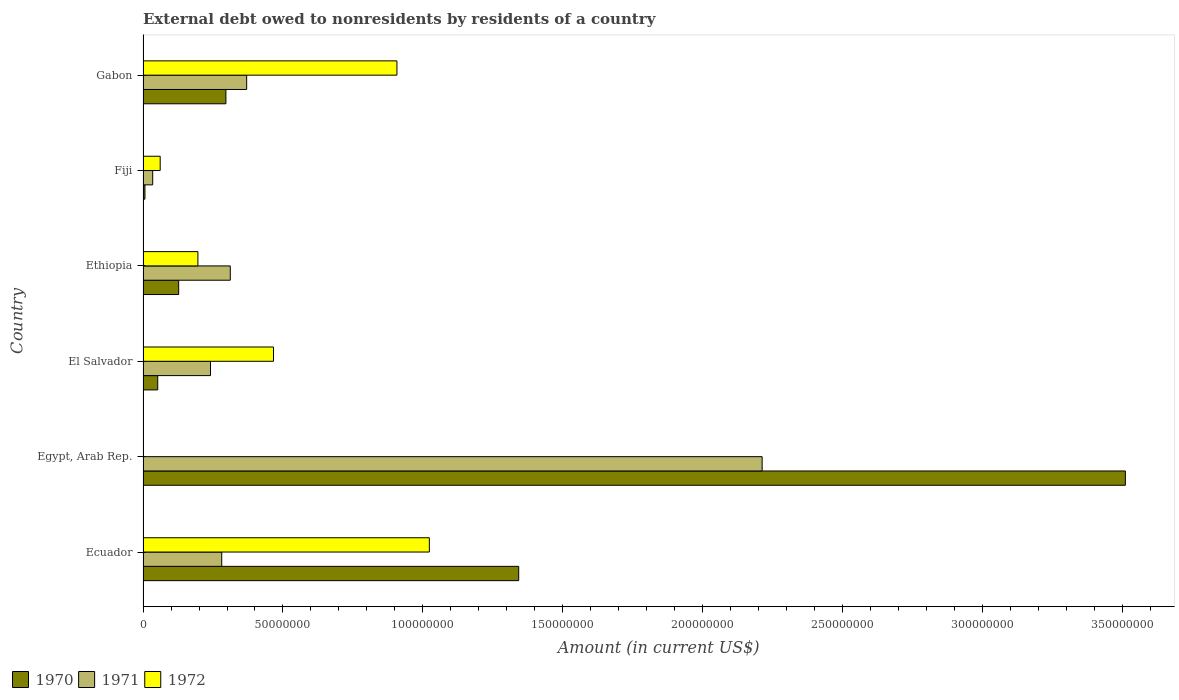How many groups of bars are there?
Offer a very short reply. 6. Are the number of bars per tick equal to the number of legend labels?
Your answer should be compact. No. Are the number of bars on each tick of the Y-axis equal?
Provide a short and direct response. No. How many bars are there on the 2nd tick from the top?
Your answer should be compact. 3. How many bars are there on the 5th tick from the bottom?
Your response must be concise. 3. What is the label of the 6th group of bars from the top?
Make the answer very short. Ecuador. What is the external debt owed by residents in 1970 in El Salvador?
Offer a very short reply. 5.25e+06. Across all countries, what is the maximum external debt owed by residents in 1971?
Ensure brevity in your answer.  2.21e+08. Across all countries, what is the minimum external debt owed by residents in 1970?
Provide a short and direct response. 6.77e+05. In which country was the external debt owed by residents in 1971 maximum?
Give a very brief answer. Egypt, Arab Rep. What is the total external debt owed by residents in 1971 in the graph?
Give a very brief answer. 3.45e+08. What is the difference between the external debt owed by residents in 1971 in Ethiopia and that in Fiji?
Keep it short and to the point. 2.77e+07. What is the difference between the external debt owed by residents in 1970 in El Salvador and the external debt owed by residents in 1972 in Ecuador?
Your response must be concise. -9.71e+07. What is the average external debt owed by residents in 1970 per country?
Give a very brief answer. 8.89e+07. What is the difference between the external debt owed by residents in 1971 and external debt owed by residents in 1970 in Egypt, Arab Rep.?
Ensure brevity in your answer.  -1.30e+08. In how many countries, is the external debt owed by residents in 1970 greater than 260000000 US$?
Your answer should be compact. 1. What is the ratio of the external debt owed by residents in 1970 in Egypt, Arab Rep. to that in Ethiopia?
Provide a succinct answer. 27.59. Is the difference between the external debt owed by residents in 1971 in Fiji and Gabon greater than the difference between the external debt owed by residents in 1970 in Fiji and Gabon?
Your answer should be compact. No. What is the difference between the highest and the second highest external debt owed by residents in 1970?
Offer a terse response. 2.17e+08. What is the difference between the highest and the lowest external debt owed by residents in 1971?
Your response must be concise. 2.18e+08. In how many countries, is the external debt owed by residents in 1970 greater than the average external debt owed by residents in 1970 taken over all countries?
Keep it short and to the point. 2. How many bars are there?
Your response must be concise. 17. How many countries are there in the graph?
Ensure brevity in your answer.  6. What is the difference between two consecutive major ticks on the X-axis?
Keep it short and to the point. 5.00e+07. Are the values on the major ticks of X-axis written in scientific E-notation?
Provide a short and direct response. No. Does the graph contain grids?
Make the answer very short. No. Where does the legend appear in the graph?
Provide a succinct answer. Bottom left. How are the legend labels stacked?
Make the answer very short. Horizontal. What is the title of the graph?
Make the answer very short. External debt owed to nonresidents by residents of a country. What is the label or title of the Y-axis?
Offer a very short reply. Country. What is the Amount (in current US$) in 1970 in Ecuador?
Offer a terse response. 1.34e+08. What is the Amount (in current US$) of 1971 in Ecuador?
Provide a succinct answer. 2.81e+07. What is the Amount (in current US$) in 1972 in Ecuador?
Offer a very short reply. 1.02e+08. What is the Amount (in current US$) in 1970 in Egypt, Arab Rep.?
Give a very brief answer. 3.51e+08. What is the Amount (in current US$) of 1971 in Egypt, Arab Rep.?
Offer a very short reply. 2.21e+08. What is the Amount (in current US$) in 1970 in El Salvador?
Your response must be concise. 5.25e+06. What is the Amount (in current US$) in 1971 in El Salvador?
Your answer should be very brief. 2.41e+07. What is the Amount (in current US$) in 1972 in El Salvador?
Keep it short and to the point. 4.66e+07. What is the Amount (in current US$) in 1970 in Ethiopia?
Ensure brevity in your answer.  1.27e+07. What is the Amount (in current US$) in 1971 in Ethiopia?
Offer a very short reply. 3.12e+07. What is the Amount (in current US$) in 1972 in Ethiopia?
Provide a succinct answer. 1.96e+07. What is the Amount (in current US$) in 1970 in Fiji?
Provide a short and direct response. 6.77e+05. What is the Amount (in current US$) in 1971 in Fiji?
Provide a short and direct response. 3.45e+06. What is the Amount (in current US$) in 1972 in Fiji?
Make the answer very short. 6.12e+06. What is the Amount (in current US$) of 1970 in Gabon?
Your answer should be very brief. 2.96e+07. What is the Amount (in current US$) of 1971 in Gabon?
Your response must be concise. 3.70e+07. What is the Amount (in current US$) of 1972 in Gabon?
Your response must be concise. 9.07e+07. Across all countries, what is the maximum Amount (in current US$) of 1970?
Your answer should be compact. 3.51e+08. Across all countries, what is the maximum Amount (in current US$) of 1971?
Provide a succinct answer. 2.21e+08. Across all countries, what is the maximum Amount (in current US$) in 1972?
Your answer should be compact. 1.02e+08. Across all countries, what is the minimum Amount (in current US$) of 1970?
Ensure brevity in your answer.  6.77e+05. Across all countries, what is the minimum Amount (in current US$) in 1971?
Provide a succinct answer. 3.45e+06. What is the total Amount (in current US$) of 1970 in the graph?
Keep it short and to the point. 5.34e+08. What is the total Amount (in current US$) in 1971 in the graph?
Your answer should be very brief. 3.45e+08. What is the total Amount (in current US$) in 1972 in the graph?
Offer a very short reply. 2.65e+08. What is the difference between the Amount (in current US$) in 1970 in Ecuador and that in Egypt, Arab Rep.?
Provide a succinct answer. -2.17e+08. What is the difference between the Amount (in current US$) in 1971 in Ecuador and that in Egypt, Arab Rep.?
Your answer should be very brief. -1.93e+08. What is the difference between the Amount (in current US$) in 1970 in Ecuador and that in El Salvador?
Ensure brevity in your answer.  1.29e+08. What is the difference between the Amount (in current US$) of 1971 in Ecuador and that in El Salvador?
Ensure brevity in your answer.  4.01e+06. What is the difference between the Amount (in current US$) of 1972 in Ecuador and that in El Salvador?
Your answer should be very brief. 5.57e+07. What is the difference between the Amount (in current US$) in 1970 in Ecuador and that in Ethiopia?
Offer a terse response. 1.22e+08. What is the difference between the Amount (in current US$) of 1971 in Ecuador and that in Ethiopia?
Your answer should be compact. -3.06e+06. What is the difference between the Amount (in current US$) of 1972 in Ecuador and that in Ethiopia?
Keep it short and to the point. 8.27e+07. What is the difference between the Amount (in current US$) of 1970 in Ecuador and that in Fiji?
Offer a terse response. 1.34e+08. What is the difference between the Amount (in current US$) of 1971 in Ecuador and that in Fiji?
Your answer should be compact. 2.47e+07. What is the difference between the Amount (in current US$) of 1972 in Ecuador and that in Fiji?
Your answer should be compact. 9.62e+07. What is the difference between the Amount (in current US$) of 1970 in Ecuador and that in Gabon?
Your answer should be very brief. 1.05e+08. What is the difference between the Amount (in current US$) of 1971 in Ecuador and that in Gabon?
Ensure brevity in your answer.  -8.92e+06. What is the difference between the Amount (in current US$) of 1972 in Ecuador and that in Gabon?
Provide a short and direct response. 1.16e+07. What is the difference between the Amount (in current US$) in 1970 in Egypt, Arab Rep. and that in El Salvador?
Provide a succinct answer. 3.46e+08. What is the difference between the Amount (in current US$) in 1971 in Egypt, Arab Rep. and that in El Salvador?
Your answer should be compact. 1.97e+08. What is the difference between the Amount (in current US$) in 1970 in Egypt, Arab Rep. and that in Ethiopia?
Give a very brief answer. 3.38e+08. What is the difference between the Amount (in current US$) of 1971 in Egypt, Arab Rep. and that in Ethiopia?
Give a very brief answer. 1.90e+08. What is the difference between the Amount (in current US$) in 1970 in Egypt, Arab Rep. and that in Fiji?
Make the answer very short. 3.50e+08. What is the difference between the Amount (in current US$) in 1971 in Egypt, Arab Rep. and that in Fiji?
Provide a short and direct response. 2.18e+08. What is the difference between the Amount (in current US$) in 1970 in Egypt, Arab Rep. and that in Gabon?
Your answer should be compact. 3.21e+08. What is the difference between the Amount (in current US$) in 1971 in Egypt, Arab Rep. and that in Gabon?
Make the answer very short. 1.84e+08. What is the difference between the Amount (in current US$) in 1970 in El Salvador and that in Ethiopia?
Provide a short and direct response. -7.48e+06. What is the difference between the Amount (in current US$) of 1971 in El Salvador and that in Ethiopia?
Ensure brevity in your answer.  -7.07e+06. What is the difference between the Amount (in current US$) in 1972 in El Salvador and that in Ethiopia?
Offer a terse response. 2.70e+07. What is the difference between the Amount (in current US$) in 1970 in El Salvador and that in Fiji?
Offer a terse response. 4.57e+06. What is the difference between the Amount (in current US$) in 1971 in El Salvador and that in Fiji?
Give a very brief answer. 2.07e+07. What is the difference between the Amount (in current US$) in 1972 in El Salvador and that in Fiji?
Give a very brief answer. 4.05e+07. What is the difference between the Amount (in current US$) in 1970 in El Salvador and that in Gabon?
Provide a succinct answer. -2.44e+07. What is the difference between the Amount (in current US$) of 1971 in El Salvador and that in Gabon?
Keep it short and to the point. -1.29e+07. What is the difference between the Amount (in current US$) of 1972 in El Salvador and that in Gabon?
Your answer should be very brief. -4.41e+07. What is the difference between the Amount (in current US$) in 1970 in Ethiopia and that in Fiji?
Keep it short and to the point. 1.20e+07. What is the difference between the Amount (in current US$) of 1971 in Ethiopia and that in Fiji?
Your answer should be very brief. 2.77e+07. What is the difference between the Amount (in current US$) in 1972 in Ethiopia and that in Fiji?
Keep it short and to the point. 1.35e+07. What is the difference between the Amount (in current US$) in 1970 in Ethiopia and that in Gabon?
Keep it short and to the point. -1.69e+07. What is the difference between the Amount (in current US$) in 1971 in Ethiopia and that in Gabon?
Your response must be concise. -5.86e+06. What is the difference between the Amount (in current US$) of 1972 in Ethiopia and that in Gabon?
Keep it short and to the point. -7.11e+07. What is the difference between the Amount (in current US$) of 1970 in Fiji and that in Gabon?
Your answer should be compact. -2.89e+07. What is the difference between the Amount (in current US$) of 1971 in Fiji and that in Gabon?
Your answer should be compact. -3.36e+07. What is the difference between the Amount (in current US$) in 1972 in Fiji and that in Gabon?
Provide a succinct answer. -8.46e+07. What is the difference between the Amount (in current US$) in 1970 in Ecuador and the Amount (in current US$) in 1971 in Egypt, Arab Rep.?
Your answer should be very brief. -8.70e+07. What is the difference between the Amount (in current US$) of 1970 in Ecuador and the Amount (in current US$) of 1971 in El Salvador?
Your response must be concise. 1.10e+08. What is the difference between the Amount (in current US$) of 1970 in Ecuador and the Amount (in current US$) of 1972 in El Salvador?
Ensure brevity in your answer.  8.76e+07. What is the difference between the Amount (in current US$) in 1971 in Ecuador and the Amount (in current US$) in 1972 in El Salvador?
Keep it short and to the point. -1.85e+07. What is the difference between the Amount (in current US$) in 1970 in Ecuador and the Amount (in current US$) in 1971 in Ethiopia?
Your response must be concise. 1.03e+08. What is the difference between the Amount (in current US$) in 1970 in Ecuador and the Amount (in current US$) in 1972 in Ethiopia?
Offer a terse response. 1.15e+08. What is the difference between the Amount (in current US$) in 1971 in Ecuador and the Amount (in current US$) in 1972 in Ethiopia?
Offer a terse response. 8.52e+06. What is the difference between the Amount (in current US$) of 1970 in Ecuador and the Amount (in current US$) of 1971 in Fiji?
Give a very brief answer. 1.31e+08. What is the difference between the Amount (in current US$) in 1970 in Ecuador and the Amount (in current US$) in 1972 in Fiji?
Ensure brevity in your answer.  1.28e+08. What is the difference between the Amount (in current US$) of 1971 in Ecuador and the Amount (in current US$) of 1972 in Fiji?
Provide a short and direct response. 2.20e+07. What is the difference between the Amount (in current US$) of 1970 in Ecuador and the Amount (in current US$) of 1971 in Gabon?
Keep it short and to the point. 9.72e+07. What is the difference between the Amount (in current US$) of 1970 in Ecuador and the Amount (in current US$) of 1972 in Gabon?
Provide a succinct answer. 4.35e+07. What is the difference between the Amount (in current US$) of 1971 in Ecuador and the Amount (in current US$) of 1972 in Gabon?
Your response must be concise. -6.26e+07. What is the difference between the Amount (in current US$) in 1970 in Egypt, Arab Rep. and the Amount (in current US$) in 1971 in El Salvador?
Provide a short and direct response. 3.27e+08. What is the difference between the Amount (in current US$) of 1970 in Egypt, Arab Rep. and the Amount (in current US$) of 1972 in El Salvador?
Ensure brevity in your answer.  3.04e+08. What is the difference between the Amount (in current US$) of 1971 in Egypt, Arab Rep. and the Amount (in current US$) of 1972 in El Salvador?
Provide a succinct answer. 1.75e+08. What is the difference between the Amount (in current US$) of 1970 in Egypt, Arab Rep. and the Amount (in current US$) of 1971 in Ethiopia?
Give a very brief answer. 3.20e+08. What is the difference between the Amount (in current US$) of 1970 in Egypt, Arab Rep. and the Amount (in current US$) of 1972 in Ethiopia?
Offer a very short reply. 3.31e+08. What is the difference between the Amount (in current US$) in 1971 in Egypt, Arab Rep. and the Amount (in current US$) in 1972 in Ethiopia?
Your response must be concise. 2.02e+08. What is the difference between the Amount (in current US$) in 1970 in Egypt, Arab Rep. and the Amount (in current US$) in 1971 in Fiji?
Ensure brevity in your answer.  3.48e+08. What is the difference between the Amount (in current US$) of 1970 in Egypt, Arab Rep. and the Amount (in current US$) of 1972 in Fiji?
Keep it short and to the point. 3.45e+08. What is the difference between the Amount (in current US$) of 1971 in Egypt, Arab Rep. and the Amount (in current US$) of 1972 in Fiji?
Provide a short and direct response. 2.15e+08. What is the difference between the Amount (in current US$) in 1970 in Egypt, Arab Rep. and the Amount (in current US$) in 1971 in Gabon?
Keep it short and to the point. 3.14e+08. What is the difference between the Amount (in current US$) of 1970 in Egypt, Arab Rep. and the Amount (in current US$) of 1972 in Gabon?
Your answer should be very brief. 2.60e+08. What is the difference between the Amount (in current US$) of 1971 in Egypt, Arab Rep. and the Amount (in current US$) of 1972 in Gabon?
Your answer should be very brief. 1.31e+08. What is the difference between the Amount (in current US$) of 1970 in El Salvador and the Amount (in current US$) of 1971 in Ethiopia?
Your answer should be compact. -2.59e+07. What is the difference between the Amount (in current US$) of 1970 in El Salvador and the Amount (in current US$) of 1972 in Ethiopia?
Your answer should be compact. -1.44e+07. What is the difference between the Amount (in current US$) of 1971 in El Salvador and the Amount (in current US$) of 1972 in Ethiopia?
Keep it short and to the point. 4.50e+06. What is the difference between the Amount (in current US$) in 1970 in El Salvador and the Amount (in current US$) in 1971 in Fiji?
Make the answer very short. 1.80e+06. What is the difference between the Amount (in current US$) of 1970 in El Salvador and the Amount (in current US$) of 1972 in Fiji?
Provide a short and direct response. -8.75e+05. What is the difference between the Amount (in current US$) of 1971 in El Salvador and the Amount (in current US$) of 1972 in Fiji?
Provide a short and direct response. 1.80e+07. What is the difference between the Amount (in current US$) of 1970 in El Salvador and the Amount (in current US$) of 1971 in Gabon?
Your answer should be very brief. -3.18e+07. What is the difference between the Amount (in current US$) of 1970 in El Salvador and the Amount (in current US$) of 1972 in Gabon?
Give a very brief answer. -8.55e+07. What is the difference between the Amount (in current US$) in 1971 in El Salvador and the Amount (in current US$) in 1972 in Gabon?
Keep it short and to the point. -6.66e+07. What is the difference between the Amount (in current US$) of 1970 in Ethiopia and the Amount (in current US$) of 1971 in Fiji?
Provide a short and direct response. 9.28e+06. What is the difference between the Amount (in current US$) in 1970 in Ethiopia and the Amount (in current US$) in 1972 in Fiji?
Your answer should be very brief. 6.61e+06. What is the difference between the Amount (in current US$) of 1971 in Ethiopia and the Amount (in current US$) of 1972 in Fiji?
Give a very brief answer. 2.51e+07. What is the difference between the Amount (in current US$) in 1970 in Ethiopia and the Amount (in current US$) in 1971 in Gabon?
Give a very brief answer. -2.43e+07. What is the difference between the Amount (in current US$) of 1970 in Ethiopia and the Amount (in current US$) of 1972 in Gabon?
Your answer should be very brief. -7.80e+07. What is the difference between the Amount (in current US$) in 1971 in Ethiopia and the Amount (in current US$) in 1972 in Gabon?
Give a very brief answer. -5.96e+07. What is the difference between the Amount (in current US$) in 1970 in Fiji and the Amount (in current US$) in 1971 in Gabon?
Offer a very short reply. -3.64e+07. What is the difference between the Amount (in current US$) of 1970 in Fiji and the Amount (in current US$) of 1972 in Gabon?
Offer a very short reply. -9.01e+07. What is the difference between the Amount (in current US$) of 1971 in Fiji and the Amount (in current US$) of 1972 in Gabon?
Offer a very short reply. -8.73e+07. What is the average Amount (in current US$) in 1970 per country?
Offer a very short reply. 8.89e+07. What is the average Amount (in current US$) in 1971 per country?
Provide a short and direct response. 5.75e+07. What is the average Amount (in current US$) of 1972 per country?
Keep it short and to the point. 4.42e+07. What is the difference between the Amount (in current US$) in 1970 and Amount (in current US$) in 1971 in Ecuador?
Ensure brevity in your answer.  1.06e+08. What is the difference between the Amount (in current US$) of 1970 and Amount (in current US$) of 1972 in Ecuador?
Ensure brevity in your answer.  3.19e+07. What is the difference between the Amount (in current US$) in 1971 and Amount (in current US$) in 1972 in Ecuador?
Provide a succinct answer. -7.42e+07. What is the difference between the Amount (in current US$) in 1970 and Amount (in current US$) in 1971 in Egypt, Arab Rep.?
Give a very brief answer. 1.30e+08. What is the difference between the Amount (in current US$) in 1970 and Amount (in current US$) in 1971 in El Salvador?
Your response must be concise. -1.89e+07. What is the difference between the Amount (in current US$) of 1970 and Amount (in current US$) of 1972 in El Salvador?
Make the answer very short. -4.14e+07. What is the difference between the Amount (in current US$) in 1971 and Amount (in current US$) in 1972 in El Salvador?
Offer a very short reply. -2.25e+07. What is the difference between the Amount (in current US$) in 1970 and Amount (in current US$) in 1971 in Ethiopia?
Your answer should be very brief. -1.84e+07. What is the difference between the Amount (in current US$) in 1970 and Amount (in current US$) in 1972 in Ethiopia?
Your answer should be very brief. -6.87e+06. What is the difference between the Amount (in current US$) in 1971 and Amount (in current US$) in 1972 in Ethiopia?
Keep it short and to the point. 1.16e+07. What is the difference between the Amount (in current US$) of 1970 and Amount (in current US$) of 1971 in Fiji?
Your response must be concise. -2.77e+06. What is the difference between the Amount (in current US$) of 1970 and Amount (in current US$) of 1972 in Fiji?
Provide a short and direct response. -5.44e+06. What is the difference between the Amount (in current US$) of 1971 and Amount (in current US$) of 1972 in Fiji?
Make the answer very short. -2.68e+06. What is the difference between the Amount (in current US$) of 1970 and Amount (in current US$) of 1971 in Gabon?
Your answer should be compact. -7.42e+06. What is the difference between the Amount (in current US$) in 1970 and Amount (in current US$) in 1972 in Gabon?
Your answer should be very brief. -6.11e+07. What is the difference between the Amount (in current US$) in 1971 and Amount (in current US$) in 1972 in Gabon?
Provide a succinct answer. -5.37e+07. What is the ratio of the Amount (in current US$) of 1970 in Ecuador to that in Egypt, Arab Rep.?
Provide a short and direct response. 0.38. What is the ratio of the Amount (in current US$) in 1971 in Ecuador to that in Egypt, Arab Rep.?
Offer a very short reply. 0.13. What is the ratio of the Amount (in current US$) of 1970 in Ecuador to that in El Salvador?
Provide a short and direct response. 25.59. What is the ratio of the Amount (in current US$) in 1971 in Ecuador to that in El Salvador?
Your answer should be very brief. 1.17. What is the ratio of the Amount (in current US$) in 1972 in Ecuador to that in El Salvador?
Provide a short and direct response. 2.2. What is the ratio of the Amount (in current US$) of 1970 in Ecuador to that in Ethiopia?
Your answer should be compact. 10.55. What is the ratio of the Amount (in current US$) in 1971 in Ecuador to that in Ethiopia?
Provide a succinct answer. 0.9. What is the ratio of the Amount (in current US$) in 1972 in Ecuador to that in Ethiopia?
Your response must be concise. 5.22. What is the ratio of the Amount (in current US$) of 1970 in Ecuador to that in Fiji?
Give a very brief answer. 198.32. What is the ratio of the Amount (in current US$) of 1971 in Ecuador to that in Fiji?
Offer a terse response. 8.16. What is the ratio of the Amount (in current US$) in 1972 in Ecuador to that in Fiji?
Provide a short and direct response. 16.72. What is the ratio of the Amount (in current US$) in 1970 in Ecuador to that in Gabon?
Offer a very short reply. 4.53. What is the ratio of the Amount (in current US$) of 1971 in Ecuador to that in Gabon?
Make the answer very short. 0.76. What is the ratio of the Amount (in current US$) of 1972 in Ecuador to that in Gabon?
Your response must be concise. 1.13. What is the ratio of the Amount (in current US$) of 1970 in Egypt, Arab Rep. to that in El Salvador?
Your answer should be very brief. 66.92. What is the ratio of the Amount (in current US$) of 1971 in Egypt, Arab Rep. to that in El Salvador?
Your answer should be very brief. 9.18. What is the ratio of the Amount (in current US$) of 1970 in Egypt, Arab Rep. to that in Ethiopia?
Ensure brevity in your answer.  27.59. What is the ratio of the Amount (in current US$) of 1971 in Egypt, Arab Rep. to that in Ethiopia?
Provide a succinct answer. 7.1. What is the ratio of the Amount (in current US$) of 1970 in Egypt, Arab Rep. to that in Fiji?
Offer a very short reply. 518.59. What is the ratio of the Amount (in current US$) in 1971 in Egypt, Arab Rep. to that in Fiji?
Offer a very short reply. 64.21. What is the ratio of the Amount (in current US$) of 1970 in Egypt, Arab Rep. to that in Gabon?
Your answer should be compact. 11.86. What is the ratio of the Amount (in current US$) of 1971 in Egypt, Arab Rep. to that in Gabon?
Your answer should be very brief. 5.97. What is the ratio of the Amount (in current US$) of 1970 in El Salvador to that in Ethiopia?
Give a very brief answer. 0.41. What is the ratio of the Amount (in current US$) in 1971 in El Salvador to that in Ethiopia?
Your answer should be compact. 0.77. What is the ratio of the Amount (in current US$) of 1972 in El Salvador to that in Ethiopia?
Your response must be concise. 2.38. What is the ratio of the Amount (in current US$) of 1970 in El Salvador to that in Fiji?
Offer a terse response. 7.75. What is the ratio of the Amount (in current US$) in 1971 in El Salvador to that in Fiji?
Your answer should be compact. 6.99. What is the ratio of the Amount (in current US$) in 1972 in El Salvador to that in Fiji?
Your answer should be very brief. 7.62. What is the ratio of the Amount (in current US$) in 1970 in El Salvador to that in Gabon?
Provide a succinct answer. 0.18. What is the ratio of the Amount (in current US$) of 1971 in El Salvador to that in Gabon?
Ensure brevity in your answer.  0.65. What is the ratio of the Amount (in current US$) in 1972 in El Salvador to that in Gabon?
Your response must be concise. 0.51. What is the ratio of the Amount (in current US$) of 1970 in Ethiopia to that in Fiji?
Your answer should be very brief. 18.8. What is the ratio of the Amount (in current US$) of 1971 in Ethiopia to that in Fiji?
Make the answer very short. 9.05. What is the ratio of the Amount (in current US$) of 1972 in Ethiopia to that in Fiji?
Offer a terse response. 3.2. What is the ratio of the Amount (in current US$) in 1970 in Ethiopia to that in Gabon?
Keep it short and to the point. 0.43. What is the ratio of the Amount (in current US$) in 1971 in Ethiopia to that in Gabon?
Provide a succinct answer. 0.84. What is the ratio of the Amount (in current US$) of 1972 in Ethiopia to that in Gabon?
Your answer should be compact. 0.22. What is the ratio of the Amount (in current US$) in 1970 in Fiji to that in Gabon?
Your answer should be compact. 0.02. What is the ratio of the Amount (in current US$) in 1971 in Fiji to that in Gabon?
Make the answer very short. 0.09. What is the ratio of the Amount (in current US$) of 1972 in Fiji to that in Gabon?
Ensure brevity in your answer.  0.07. What is the difference between the highest and the second highest Amount (in current US$) of 1970?
Your answer should be compact. 2.17e+08. What is the difference between the highest and the second highest Amount (in current US$) in 1971?
Provide a short and direct response. 1.84e+08. What is the difference between the highest and the second highest Amount (in current US$) of 1972?
Ensure brevity in your answer.  1.16e+07. What is the difference between the highest and the lowest Amount (in current US$) of 1970?
Offer a terse response. 3.50e+08. What is the difference between the highest and the lowest Amount (in current US$) in 1971?
Offer a very short reply. 2.18e+08. What is the difference between the highest and the lowest Amount (in current US$) of 1972?
Offer a terse response. 1.02e+08. 